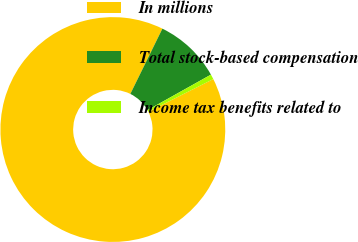Convert chart to OTSL. <chart><loc_0><loc_0><loc_500><loc_500><pie_chart><fcel>In millions<fcel>Total stock-based compensation<fcel>Income tax benefits related to<nl><fcel>89.68%<fcel>9.61%<fcel>0.71%<nl></chart> 